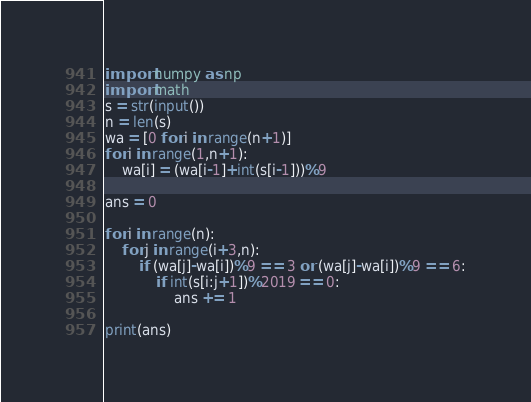<code> <loc_0><loc_0><loc_500><loc_500><_Python_>import numpy as np
import math
s = str(input())
n = len(s)
wa = [0 for i in range(n+1)]
for i in range(1,n+1):
    wa[i] = (wa[i-1]+int(s[i-1]))%9

ans = 0

for i in range(n):
    for j in range(i+3,n):
        if (wa[j]-wa[i])%9 == 3 or (wa[j]-wa[i])%9 == 6:
            if int(s[i:j+1])%2019 == 0:
                ans += 1

print(ans)
</code> 